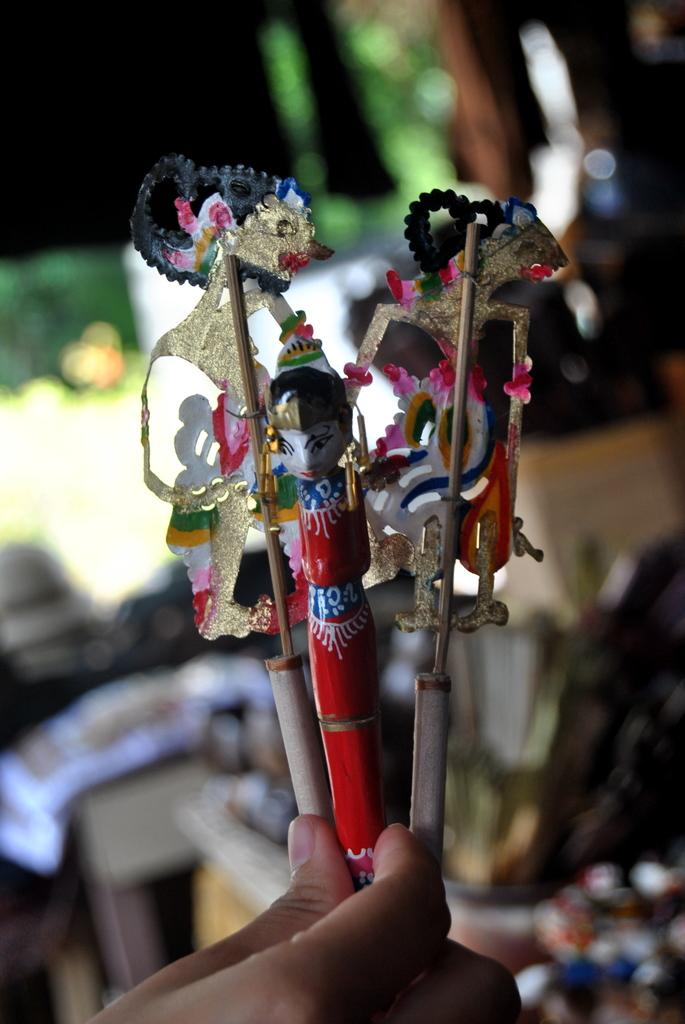What is the person's hand holding in the image? There is a person's hand holding a toy in the image. Can you describe the background of the image? The background of the image is blurry. What type of hill can be seen in the background of the image? There is no hill visible in the image; the background is blurry. Is there an airplane flying in the background of the image? There is no airplane present in the image; the background is blurry. 